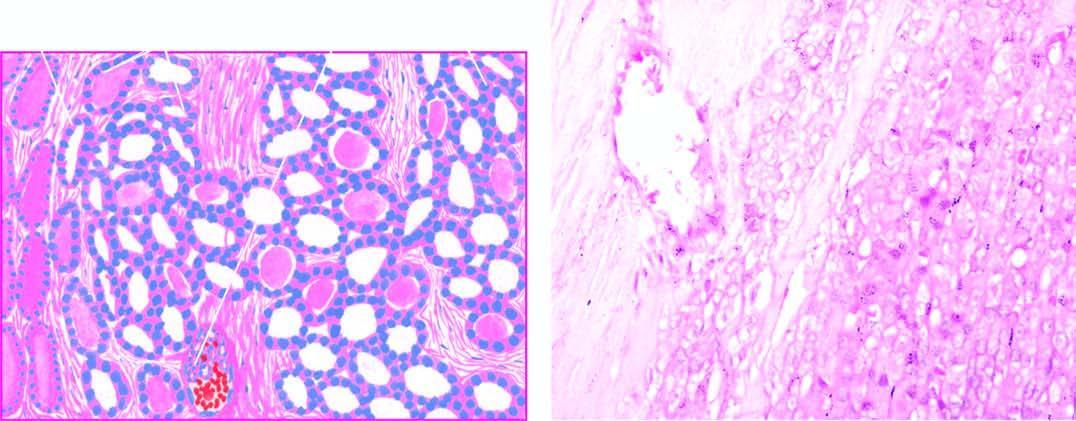s there mild pleomorphism?
Answer the question using a single word or phrase. Yes 